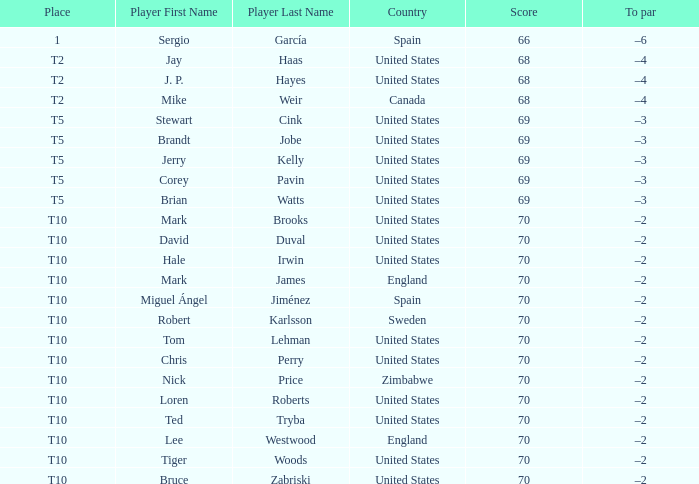What was the highest score of t5 place finisher brandt jobe? 69.0. 